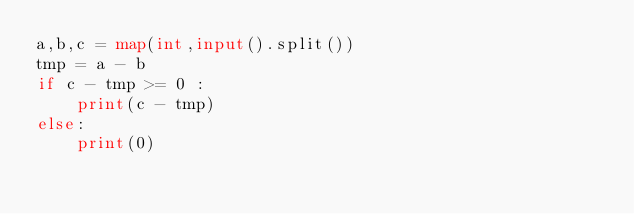<code> <loc_0><loc_0><loc_500><loc_500><_Python_>a,b,c = map(int,input().split())
tmp = a - b
if c - tmp >= 0 :
    print(c - tmp)
else:
    print(0)</code> 